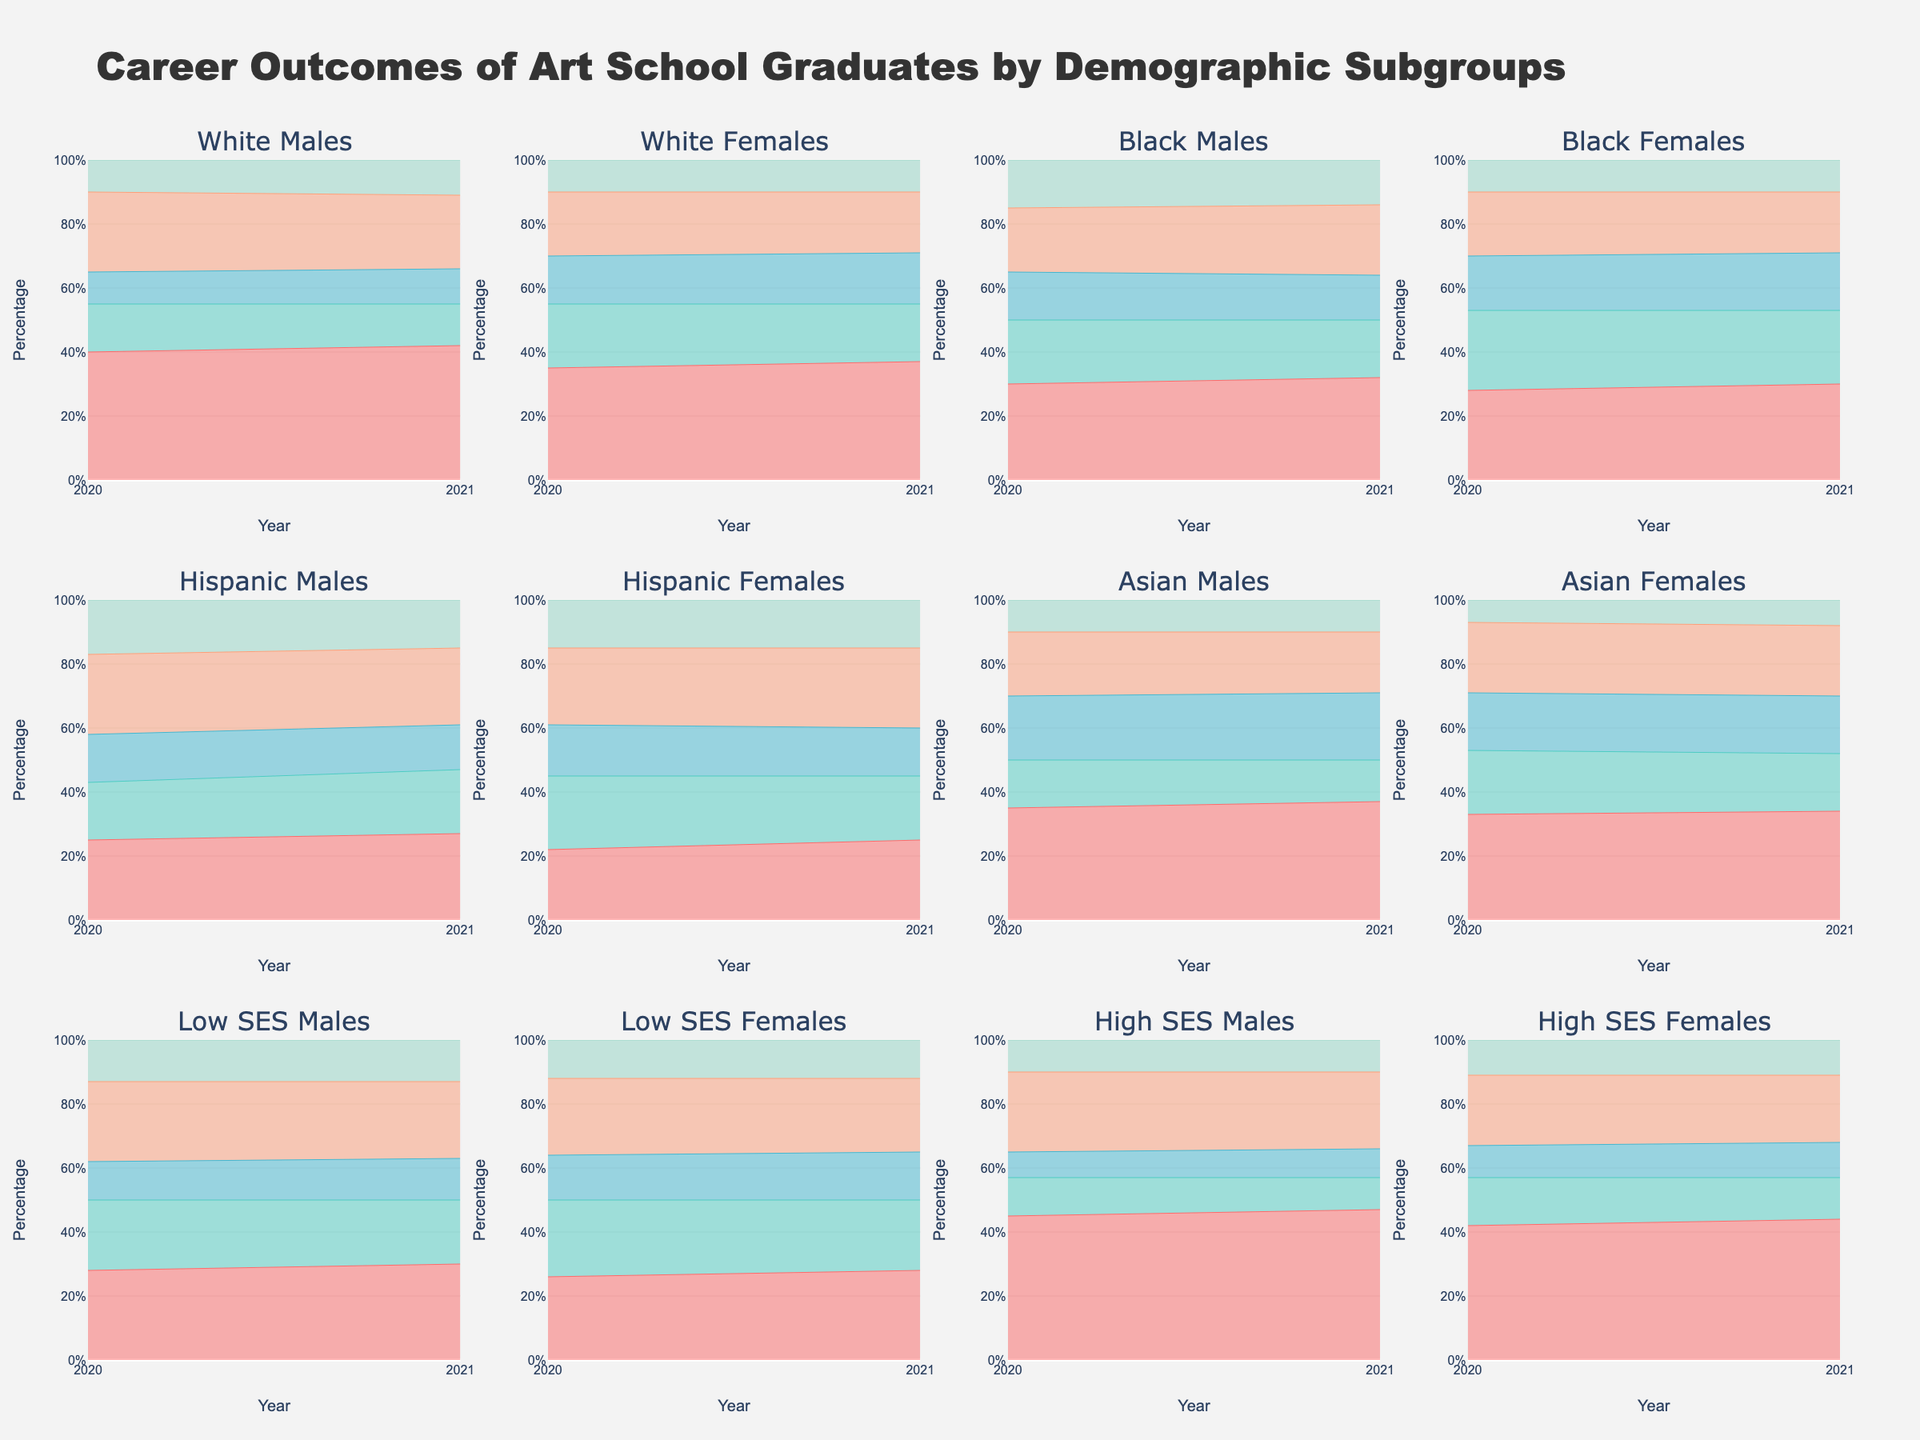How many subplots are there in the figure? The figure is divided into multiple subplots, each representing a distinct demographic subgroup. Specifically, the demographic subgroups are listed as 'White Males', 'White Females', 'Black Males', 'Black Females', 'Hispanic Males', 'Hispanic Females', 'Asian Males', 'Asian Females', 'Low SES Males', 'Low SES Females', 'High SES Males', and 'High SES Females'. Counting these, you get 12 subplots.
Answer: 12 What is the title of the plot? The title is prominently displayed at the top of the figure and reads "Career Outcomes of Art School Graduates by Demographic Subgroups".
Answer: Career Outcomes of Art School Graduates by Demographic Subgroups Which subgroup had the highest percentage of graduates 'Employed in Field' in 2021? To determine this, look at the 'Employed in Field' category for all subgroups in the year 2021. The figure shows 'High SES Males' with a percentage of 47%.
Answer: High SES Males Compare the percentage of 'Black Females' and 'Hispanic Females' in 'Further Education' in 2020. Which is higher? Examine the subplot for 'Black Females' and 'Hispanic Females' and focus on the year 2020 under the 'Further Education' segment. 'Black Females' have 17%, while 'Hispanic Females' have 16%. Thus, 'Black Females' have a higher percentage.
Answer: Black Females What is the total percentage of 'White Females' in 2020 across all career outcome categories? To find this, sum up the percentages for 'White Females' in 2020 across all categories: Employed in Field (35%), Self-employed/Freelance (20%), Further Education (15%), Other Professional Fields (20%), Unemployed (10%). Adding them up gives 35 + 20 + 15 + 20 + 10 = 100%.
Answer: 100% Did the percentage of 'Low SES Females' who were 'Unemployed' change from 2020 to 2021? If yes, how? Check the 'Unemployed' percentage for 'Low SES Females' for both 2020 and 2021 subplots. It remains at 12% in both years, hence there is no change.
Answer: No change For 'Asian Males', did the percentage increase or decrease in 'Further Education' from 2020 to 2021? In the 'Asian Males' subplot, look at the 'Further Education' category for the years 2020 (20%) and 2021 (21%). There is an increase of 1%.
Answer: Increase What is the difference in the 'Unemployed' percentage between 'High SES Females' and 'Low SES Males' in 2021? The subplot shows 'High SES Females' with 11% in 'Unemployed' for 2021 and 'Low SES Males' with 13% in 'Unemployed' for 2021. The difference is 13% - 11% = 2%.
Answer: 2% Among 'White Males,' which year had a higher proportion of 'Self-employed/Freelance' graduates? For 'White Males,' observe the 'Self-employed/Freelance' percentages for 2020 (15%) and 2021 (13%). The year 2020 had a higher proportion.
Answer: 2020 Are 'Black Males' more likely to be 'Unemployed' than 'White Females' in 2021? Look at the 'Unemployed' percentages in 2021 for 'Black Males' (14%) and 'White Females' (10%). 'Black Males' are indeed more likely to be 'Unemployed'.
Answer: Yes 